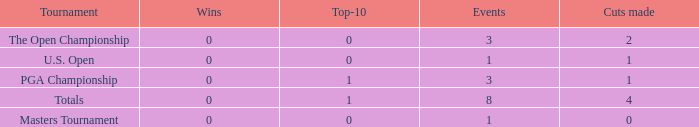For events with under 3 times played and fewer than 1 cut made, what is the total number of top-10 finishes? 1.0. Would you be able to parse every entry in this table? {'header': ['Tournament', 'Wins', 'Top-10', 'Events', 'Cuts made'], 'rows': [['The Open Championship', '0', '0', '3', '2'], ['U.S. Open', '0', '0', '1', '1'], ['PGA Championship', '0', '1', '3', '1'], ['Totals', '0', '1', '8', '4'], ['Masters Tournament', '0', '0', '1', '0']]} 